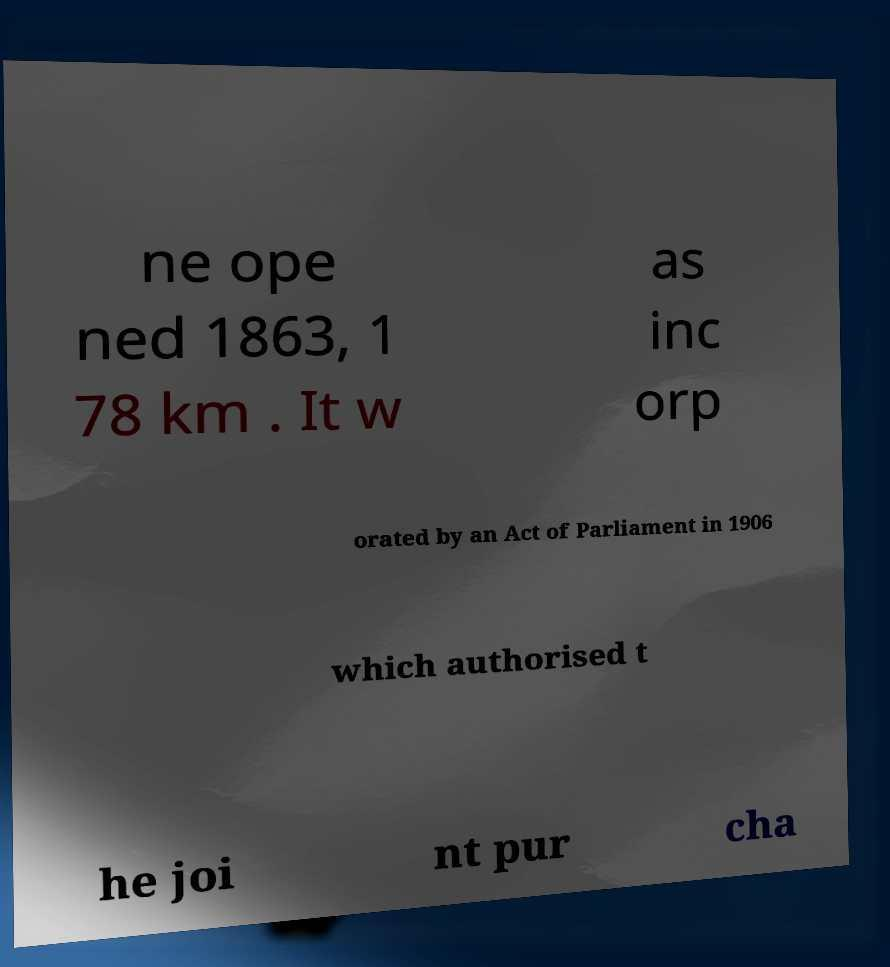I need the written content from this picture converted into text. Can you do that? ne ope ned 1863, 1 78 km . It w as inc orp orated by an Act of Parliament in 1906 which authorised t he joi nt pur cha 